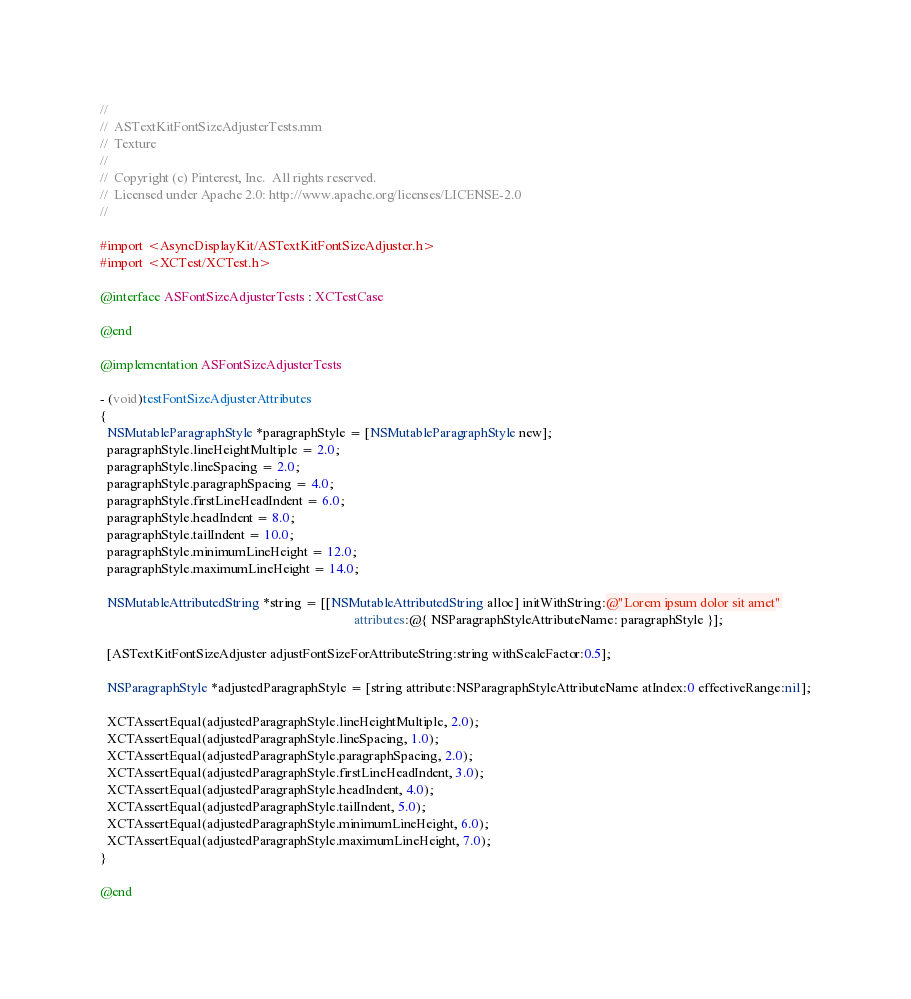<code> <loc_0><loc_0><loc_500><loc_500><_ObjectiveC_>//
//  ASTextKitFontSizeAdjusterTests.mm
//  Texture
//
//  Copyright (c) Pinterest, Inc.  All rights reserved.
//  Licensed under Apache 2.0: http://www.apache.org/licenses/LICENSE-2.0
//

#import <AsyncDisplayKit/ASTextKitFontSizeAdjuster.h>
#import <XCTest/XCTest.h>

@interface ASFontSizeAdjusterTests : XCTestCase

@end

@implementation ASFontSizeAdjusterTests

- (void)testFontSizeAdjusterAttributes
{
  NSMutableParagraphStyle *paragraphStyle = [NSMutableParagraphStyle new];
  paragraphStyle.lineHeightMultiple = 2.0;
  paragraphStyle.lineSpacing = 2.0;
  paragraphStyle.paragraphSpacing = 4.0;
  paragraphStyle.firstLineHeadIndent = 6.0;
  paragraphStyle.headIndent = 8.0;
  paragraphStyle.tailIndent = 10.0;
  paragraphStyle.minimumLineHeight = 12.0;
  paragraphStyle.maximumLineHeight = 14.0;

  NSMutableAttributedString *string = [[NSMutableAttributedString alloc] initWithString:@"Lorem ipsum dolor sit amet"
                                                                             attributes:@{ NSParagraphStyleAttributeName: paragraphStyle }];

  [ASTextKitFontSizeAdjuster adjustFontSizeForAttributeString:string withScaleFactor:0.5];

  NSParagraphStyle *adjustedParagraphStyle = [string attribute:NSParagraphStyleAttributeName atIndex:0 effectiveRange:nil];

  XCTAssertEqual(adjustedParagraphStyle.lineHeightMultiple, 2.0);
  XCTAssertEqual(adjustedParagraphStyle.lineSpacing, 1.0);
  XCTAssertEqual(adjustedParagraphStyle.paragraphSpacing, 2.0);
  XCTAssertEqual(adjustedParagraphStyle.firstLineHeadIndent, 3.0);
  XCTAssertEqual(adjustedParagraphStyle.headIndent, 4.0);
  XCTAssertEqual(adjustedParagraphStyle.tailIndent, 5.0);
  XCTAssertEqual(adjustedParagraphStyle.minimumLineHeight, 6.0);
  XCTAssertEqual(adjustedParagraphStyle.maximumLineHeight, 7.0);
}

@end
</code> 